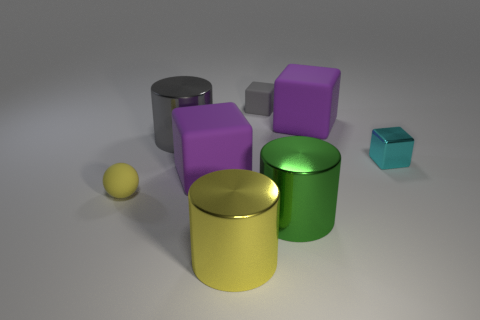What is the size of the cyan thing?
Provide a succinct answer. Small. Do the gray cube and the gray metallic cylinder have the same size?
Ensure brevity in your answer.  No. What color is the shiny object that is both right of the gray shiny object and behind the rubber ball?
Keep it short and to the point. Cyan. How many cyan cubes have the same material as the big gray cylinder?
Make the answer very short. 1. How many large yellow shiny objects are there?
Offer a terse response. 1. Does the green metal object have the same size as the gray thing that is left of the gray rubber block?
Your answer should be compact. Yes. What is the material of the small cube that is in front of the metal cylinder that is behind the small ball?
Make the answer very short. Metal. There is a shiny cylinder to the left of the big matte block that is to the left of the big purple thing behind the tiny cyan metal cube; what is its size?
Give a very brief answer. Large. Do the green shiny thing and the big purple object that is to the left of the yellow metallic thing have the same shape?
Give a very brief answer. No. What is the yellow ball made of?
Your response must be concise. Rubber. 